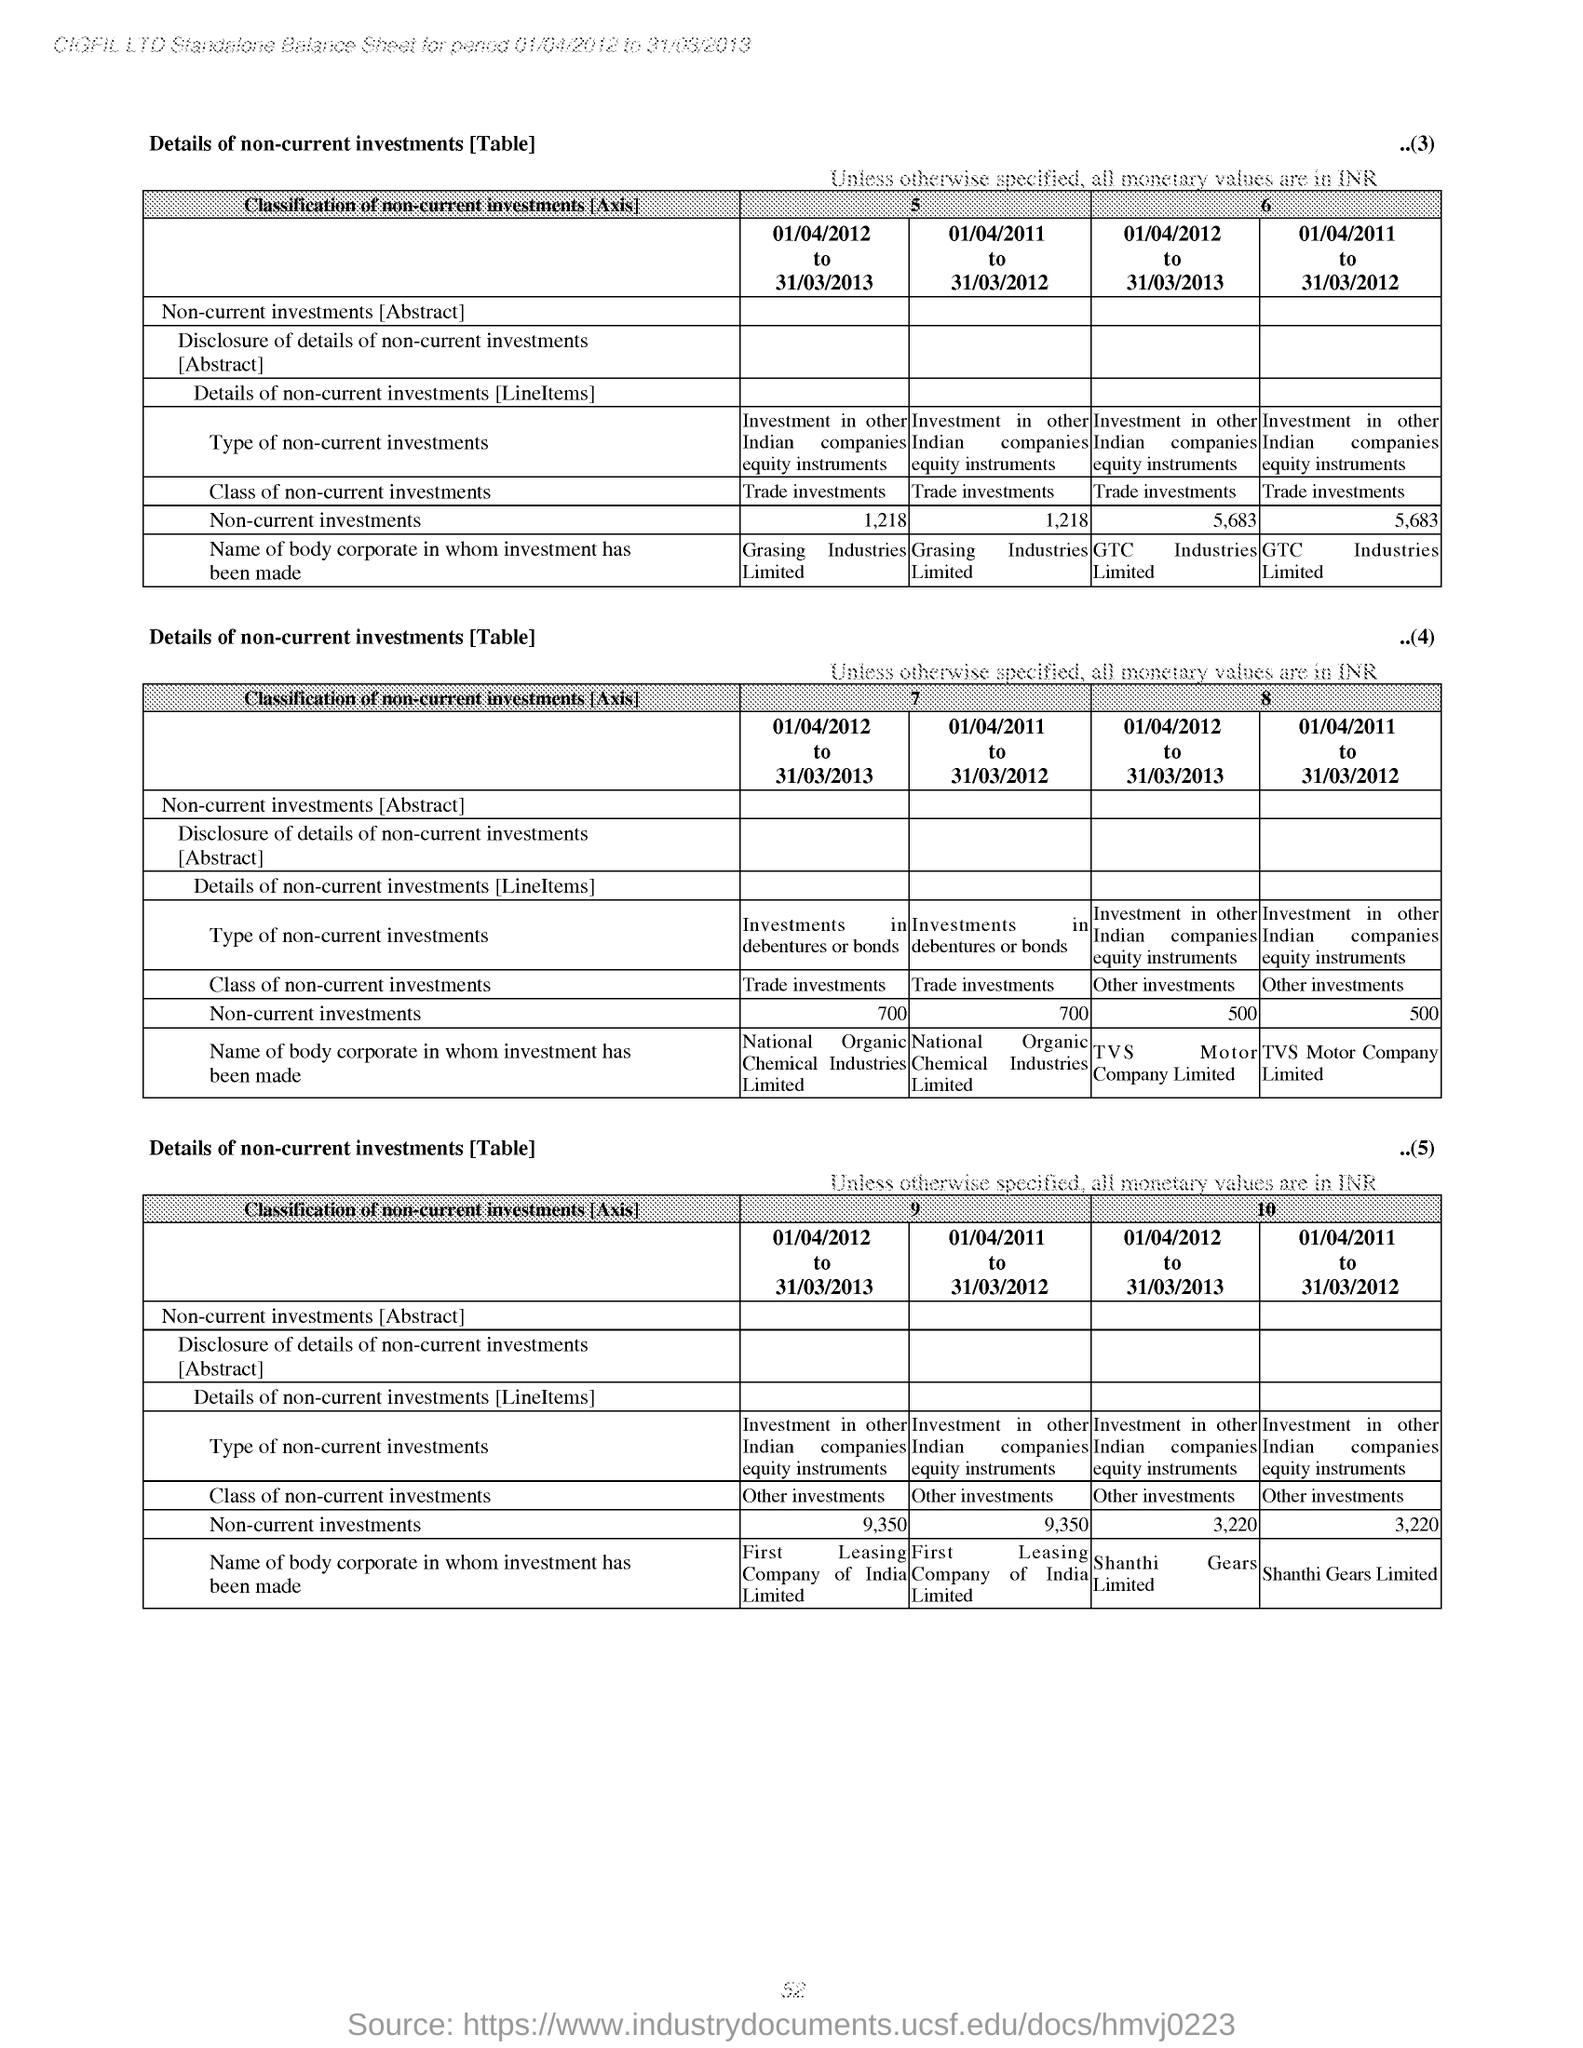What is the table heading?
Offer a terse response. Details of non-current investments. 